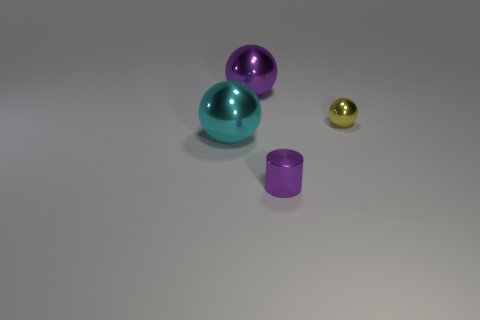Subtract all yellow shiny spheres. How many spheres are left? 2 Add 4 large green matte blocks. How many objects exist? 8 Subtract all gray balls. Subtract all blue cylinders. How many balls are left? 3 Subtract all balls. How many objects are left? 1 Add 3 purple metallic spheres. How many purple metallic spheres exist? 4 Subtract 1 cyan spheres. How many objects are left? 3 Subtract all gray things. Subtract all cylinders. How many objects are left? 3 Add 3 small purple shiny cylinders. How many small purple shiny cylinders are left? 4 